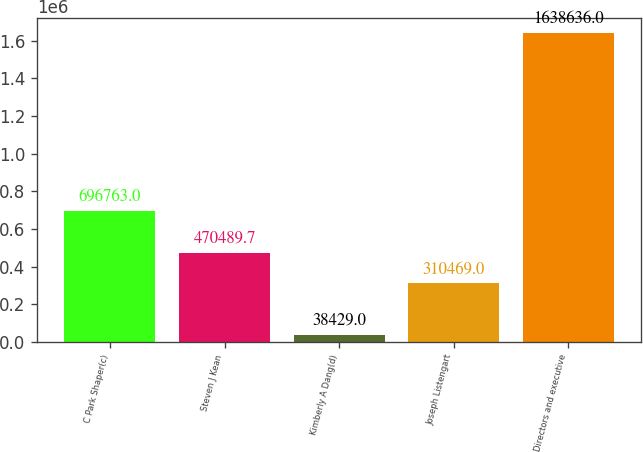Convert chart to OTSL. <chart><loc_0><loc_0><loc_500><loc_500><bar_chart><fcel>C Park Shaper(c)<fcel>Steven J Kean<fcel>Kimberly A Dang(d)<fcel>Joseph Listengart<fcel>Directors and executive<nl><fcel>696763<fcel>470490<fcel>38429<fcel>310469<fcel>1.63864e+06<nl></chart> 